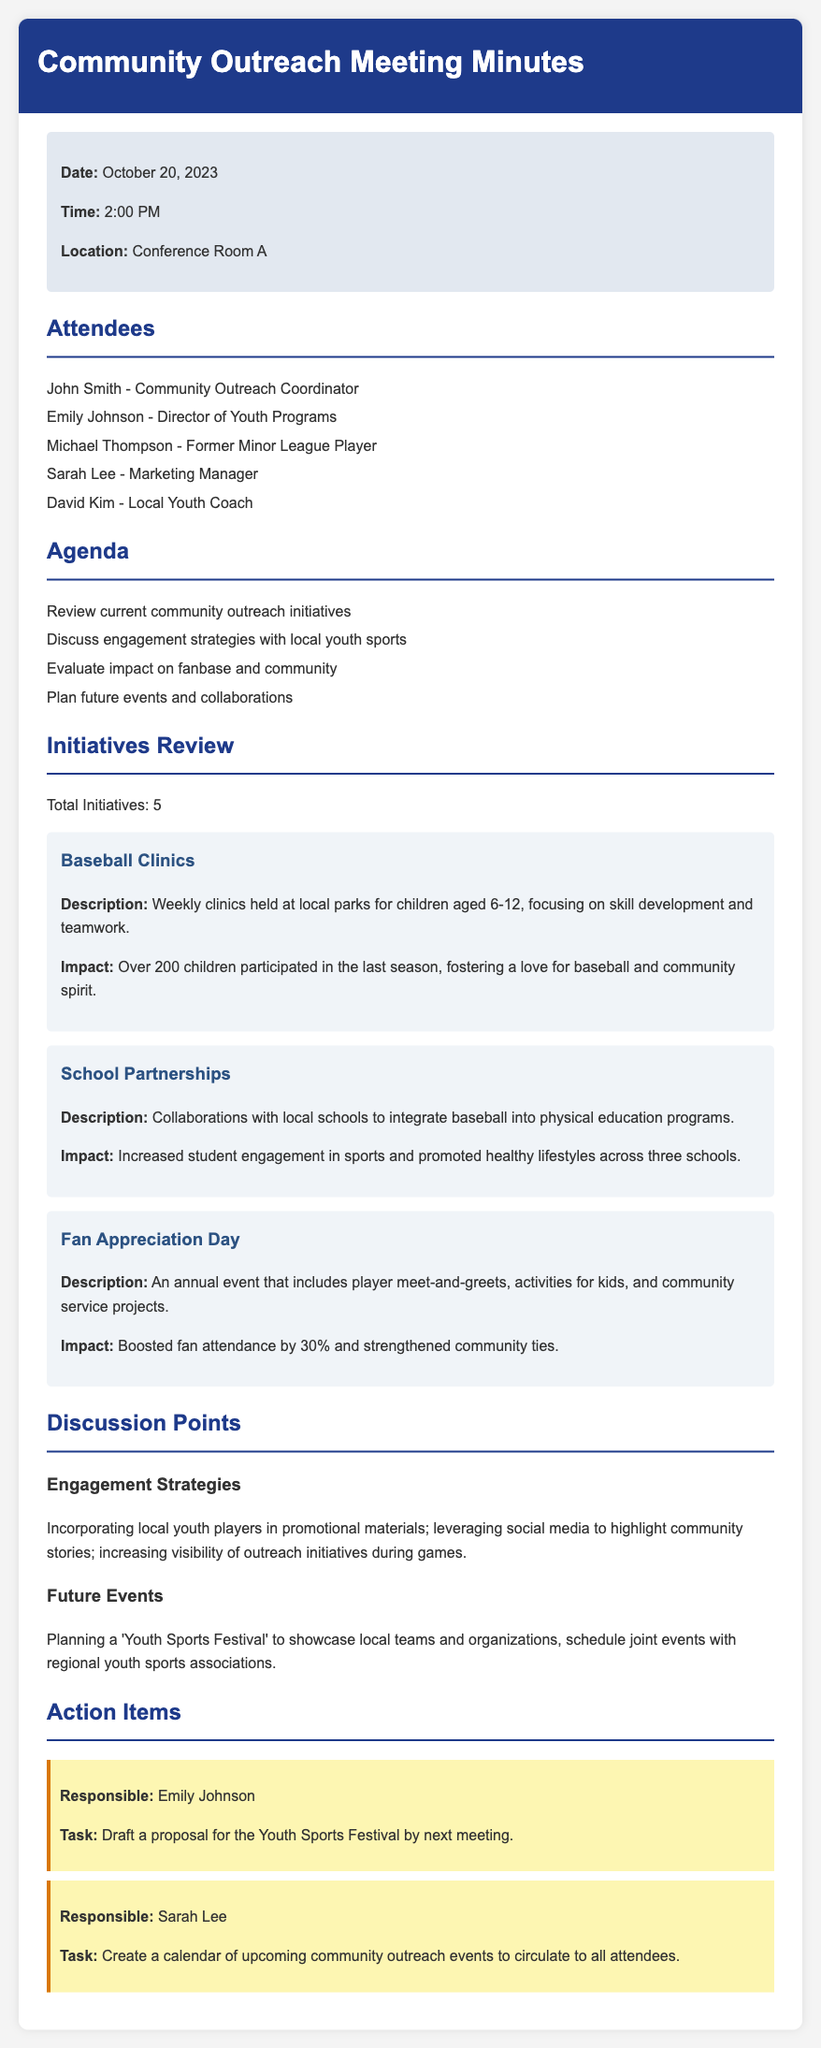What is the date of the meeting? The meeting date is stated in the meta-info section of the document.
Answer: October 20, 2023 Who is the Community Outreach Coordinator? The document lists attendees, including their titles and names.
Answer: John Smith How many total initiatives were reviewed? The total number of initiatives is specifically mentioned in the Initiatives Review section.
Answer: 5 What is the focus age range for the Baseball Clinics? The age range for the clinics is provided in the description section of the corresponding initiative.
Answer: 6-12 What is one proposed future event mentioned? The document includes a discussion point about planning future events.
Answer: Youth Sports Festival What percentage did fan attendance boost during the Fan Appreciation Day? The impact of the event is explicitly stated in the description of the initiative.
Answer: 30% What task is Emily Johnson responsible for? The action items outline specific responsibilities assigned to attendees.
Answer: Draft a proposal for the Youth Sports Festival by next meeting Which local roles are being incorporated in promotional materials according to the discussion? Engagement strategies highlight specific community involvement mentioned in the meeting.
Answer: Local youth players 